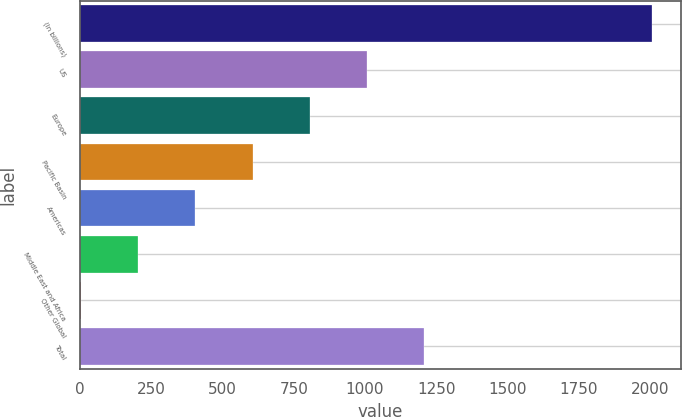Convert chart. <chart><loc_0><loc_0><loc_500><loc_500><bar_chart><fcel>(In billions)<fcel>US<fcel>Europe<fcel>Pacific Basin<fcel>Americas<fcel>Middle East and Africa<fcel>Other Global<fcel>Total<nl><fcel>2008<fcel>1006.35<fcel>806.02<fcel>605.69<fcel>405.36<fcel>205.03<fcel>4.7<fcel>1206.68<nl></chart> 